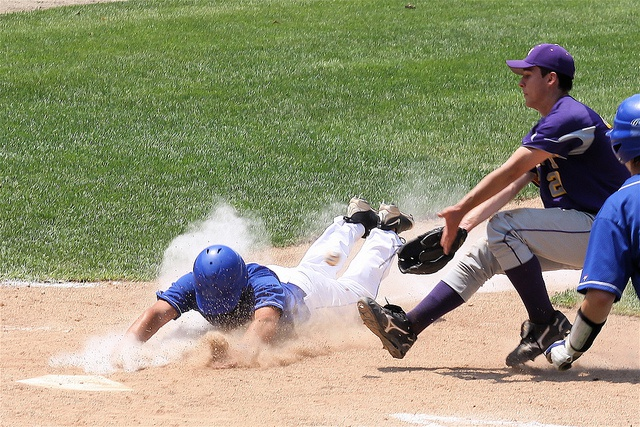Describe the objects in this image and their specific colors. I can see people in tan, black, gray, and maroon tones, people in tan, lavender, navy, and black tones, people in lightgray, black, blue, and navy tones, baseball glove in lightgray, black, gray, white, and maroon tones, and sports ball in lightgray, tan, and darkgray tones in this image. 